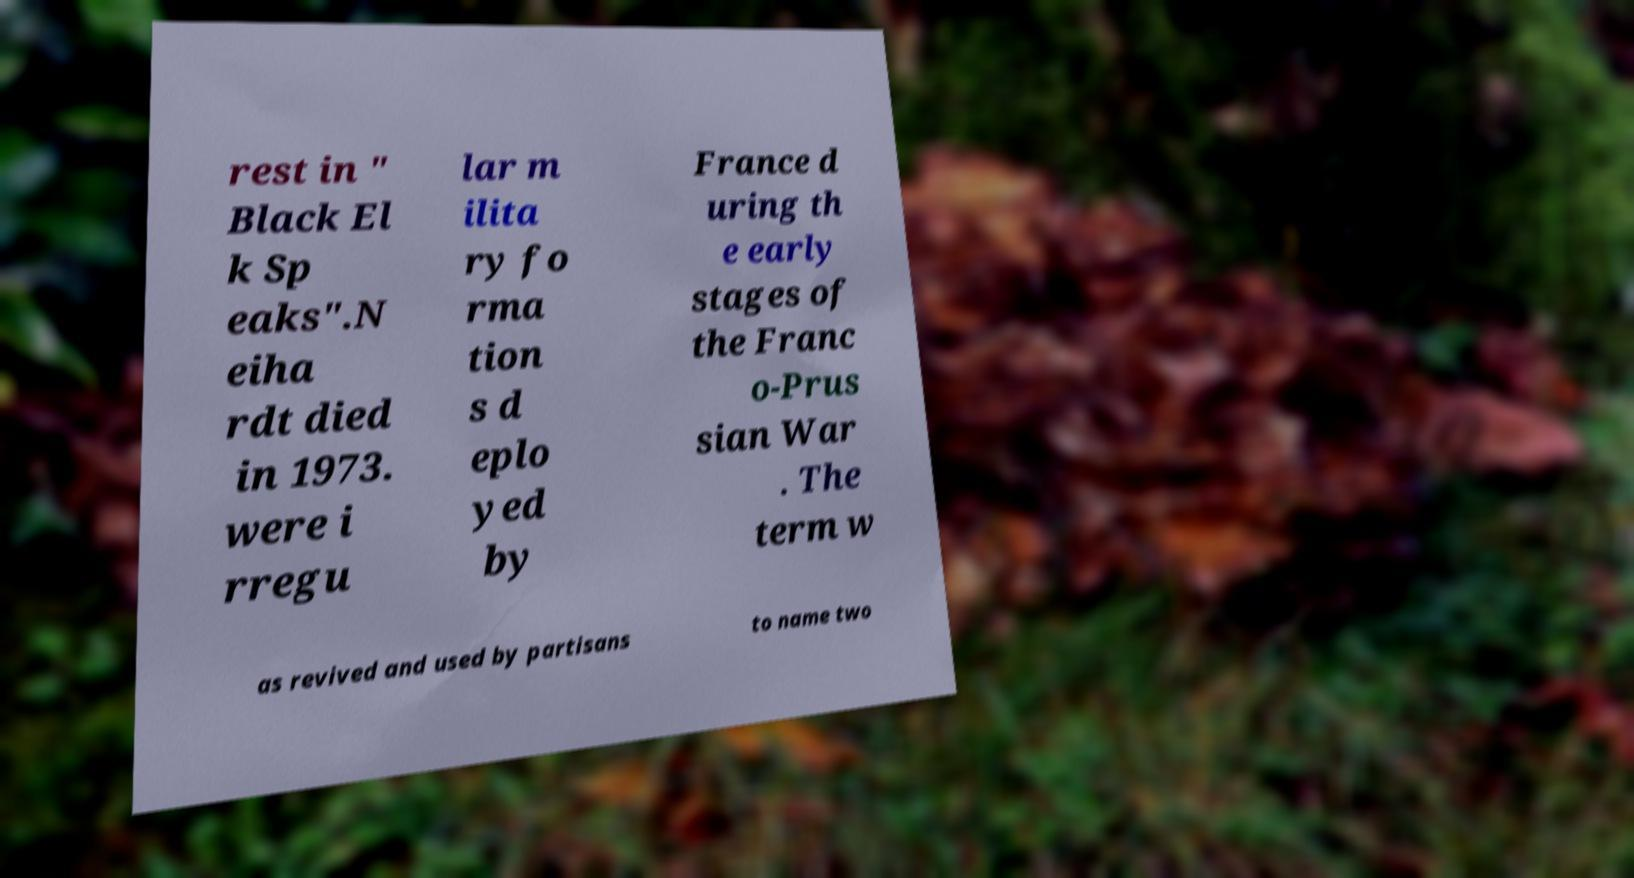Could you assist in decoding the text presented in this image and type it out clearly? rest in " Black El k Sp eaks".N eiha rdt died in 1973. were i rregu lar m ilita ry fo rma tion s d eplo yed by France d uring th e early stages of the Franc o-Prus sian War . The term w as revived and used by partisans to name two 